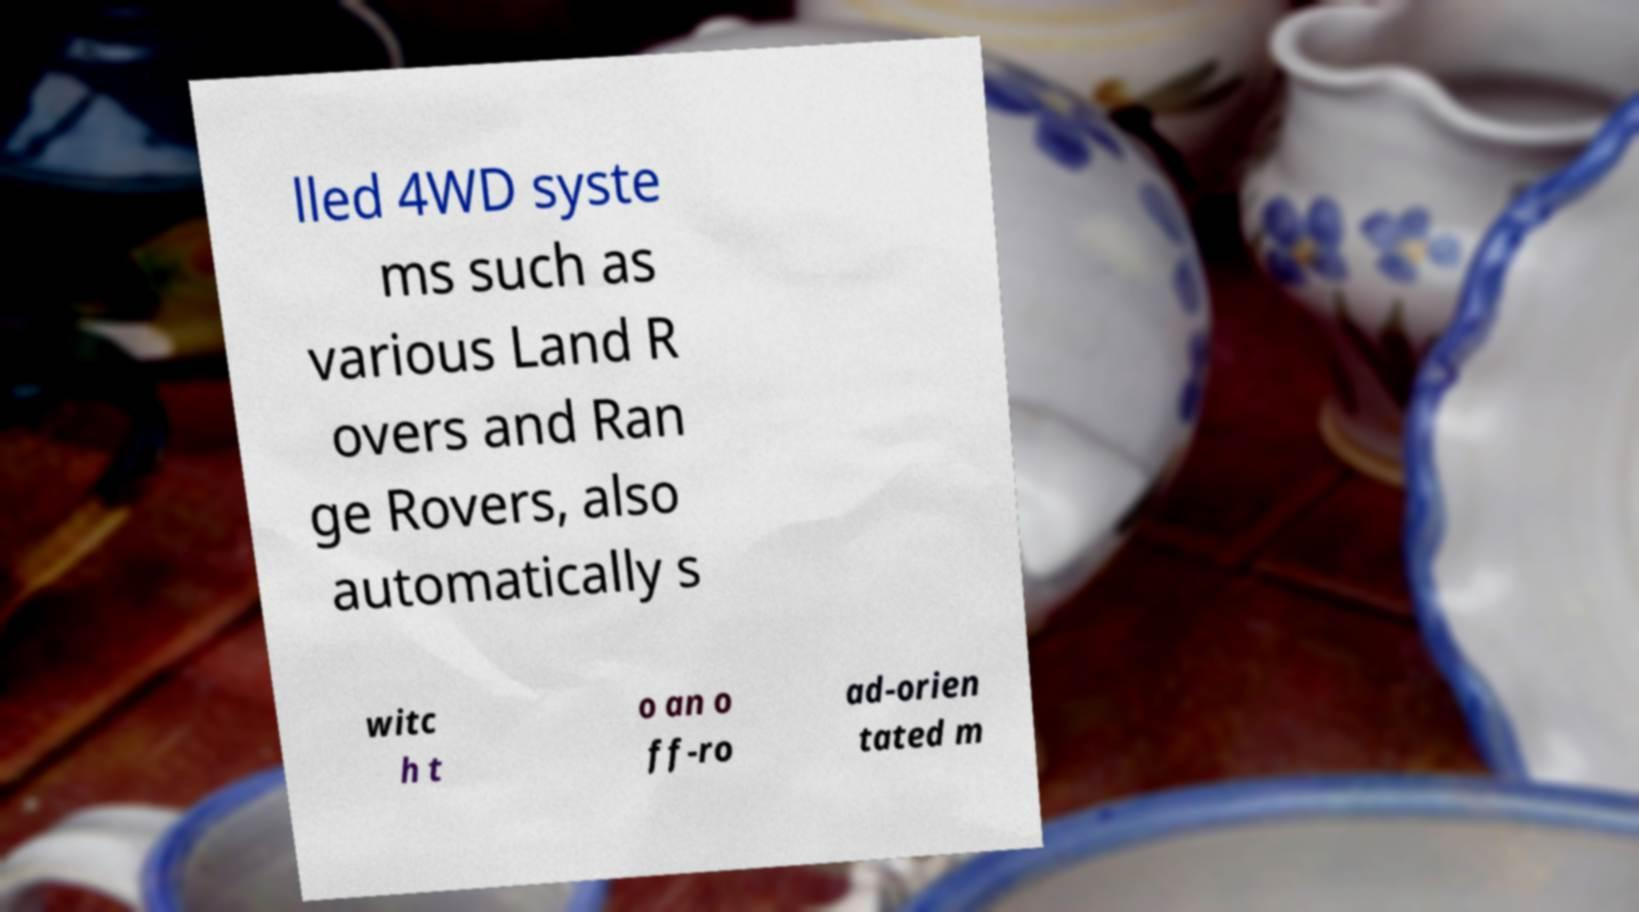Please read and relay the text visible in this image. What does it say? lled 4WD syste ms such as various Land R overs and Ran ge Rovers, also automatically s witc h t o an o ff-ro ad-orien tated m 